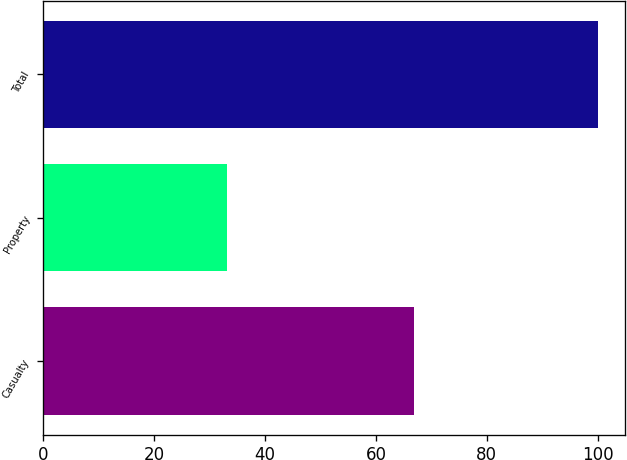Convert chart. <chart><loc_0><loc_0><loc_500><loc_500><bar_chart><fcel>Casualty<fcel>Property<fcel>Total<nl><fcel>66.9<fcel>33.1<fcel>100<nl></chart> 